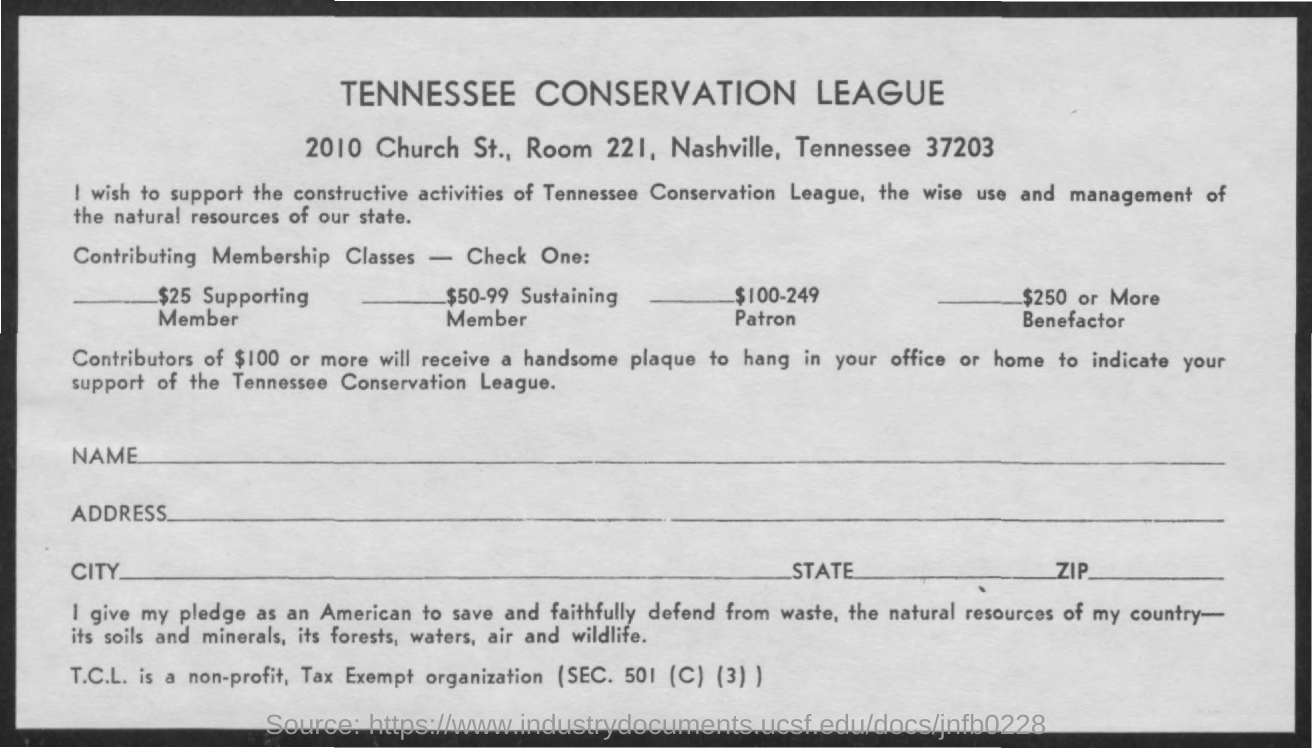Point out several critical features in this image. What is the room number that was not mentioned? The room number 221... The full form of TCL is Tennessee Conservation League. The title mentioned in bold letters is 'Tennessee Conservation League.' The section mentioned is Section 501 (C) (3). 